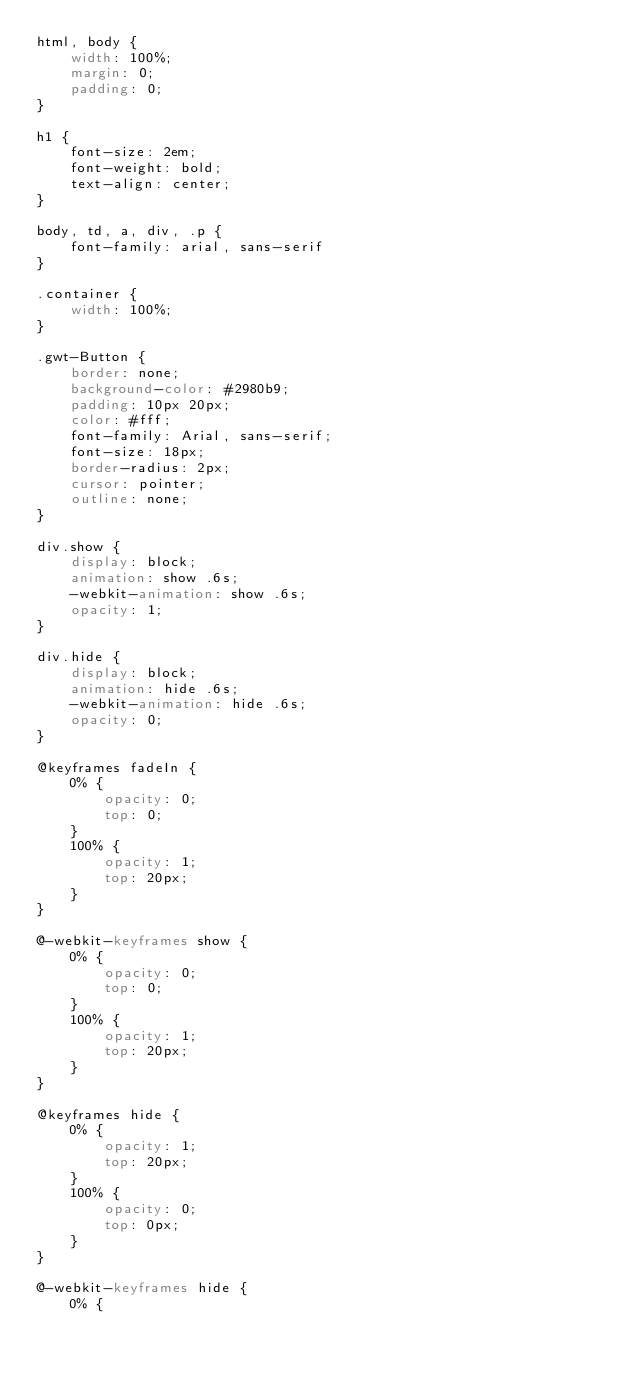Convert code to text. <code><loc_0><loc_0><loc_500><loc_500><_CSS_>html, body {
    width: 100%;
    margin: 0;
    padding: 0;
}

h1 {
    font-size: 2em;
    font-weight: bold;
    text-align: center;
}

body, td, a, div, .p {
    font-family: arial, sans-serif
}

.container {
    width: 100%;
}

.gwt-Button {
    border: none;
    background-color: #2980b9;
    padding: 10px 20px;
    color: #fff;
    font-family: Arial, sans-serif;
    font-size: 18px;
    border-radius: 2px;
    cursor: pointer;
    outline: none;
}

div.show {
    display: block;
    animation: show .6s;
    -webkit-animation: show .6s;
    opacity: 1;
}

div.hide {
    display: block;
    animation: hide .6s;
    -webkit-animation: hide .6s;
    opacity: 0;
}

@keyframes fadeIn {
    0% {
        opacity: 0;
        top: 0;
    }
    100% {
        opacity: 1;
        top: 20px;
    }
}

@-webkit-keyframes show {
    0% {
        opacity: 0;
        top: 0;
    }
    100% {
        opacity: 1;
        top: 20px;
    }
}

@keyframes hide {
    0% {
        opacity: 1;
        top: 20px;
    }
    100% {
        opacity: 0;
        top: 0px;
    }
}

@-webkit-keyframes hide {
    0% {</code> 